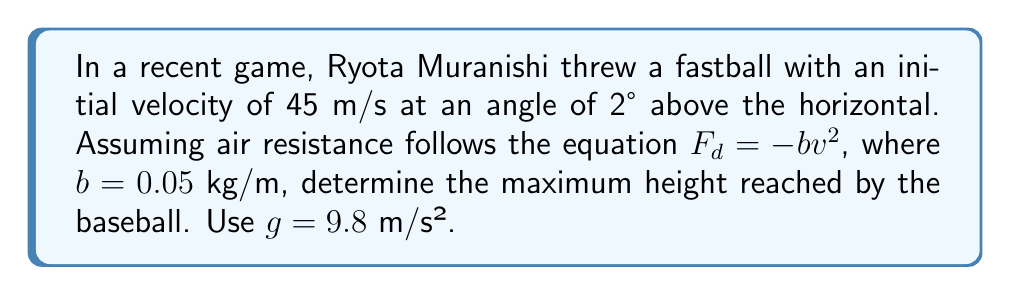Can you solve this math problem? Let's approach this step-by-step:

1) First, we need to consider the equations of motion for a projectile with air resistance:

   $$\frac{d^2x}{dt^2} = -\frac{b}{m}v\frac{dx}{dt}$$
   $$\frac{d^2y}{dt^2} = -g -\frac{b}{m}v\frac{dy}{dt}$$

   Where $v = \sqrt{(\frac{dx}{dt})^2 + (\frac{dy}{dt})^2}$

2) These equations are nonlinear and don't have a simple analytical solution. However, we can use the concept of terminal velocity to simplify our problem.

3) The terminal velocity in the vertical direction is reached when the air resistance equals the weight of the ball:

   $$bv_t^2 = mg$$

4) Solving for $v_t$:

   $$v_t = \sqrt{\frac{mg}{b}}$$

5) Assuming a baseball mass of about 0.145 kg:

   $$v_t = \sqrt{\frac{0.145 \cdot 9.8}{0.05}} \approx 5.3 \text{ m/s}$$

6) The initial vertical velocity component is:

   $$v_y = 45 \sin(2°) \approx 1.57 \text{ m/s}$$

7) Since $v_y < v_t$, the ball won't reach terminal velocity. We can approximate the motion as a parabola with an effective acceleration less than $g$ due to air resistance.

8) Let's estimate the effective acceleration as $g_{eff} = g(1 - \frac{v_y^2}{v_t^2}) \approx 9.7 \text{ m/s²}$

9) Now we can use the equation for maximum height of a projectile:

   $$h_{max} = \frac{v_y^2}{2g_{eff}}$$

10) Plugging in our values:

    $$h_{max} = \frac{1.57^2}{2 \cdot 9.7} \approx 0.13 \text{ m}$$
Answer: 0.13 m 